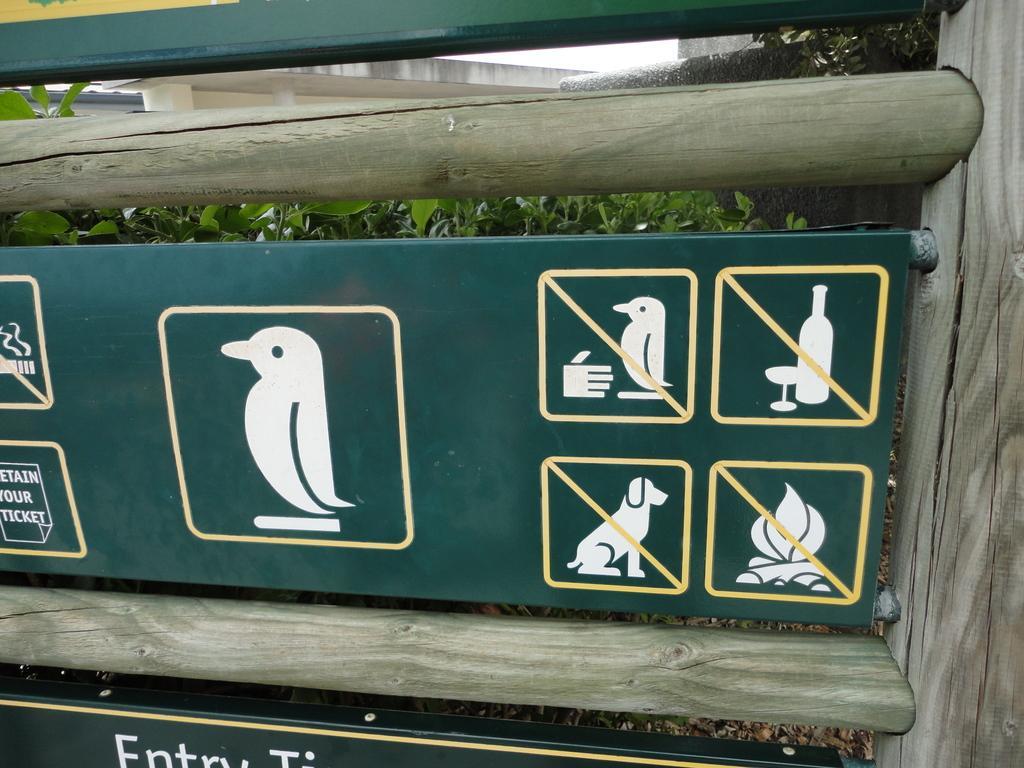Please provide a concise description of this image. In this image there are metal boards to the wooden poles. There is text on the boards. There are pictures of birds, a dog, bonfire, a bottle and a glass on the board. Behind the boards there are leaves of a plants and a wall. At the top there is the sky. 